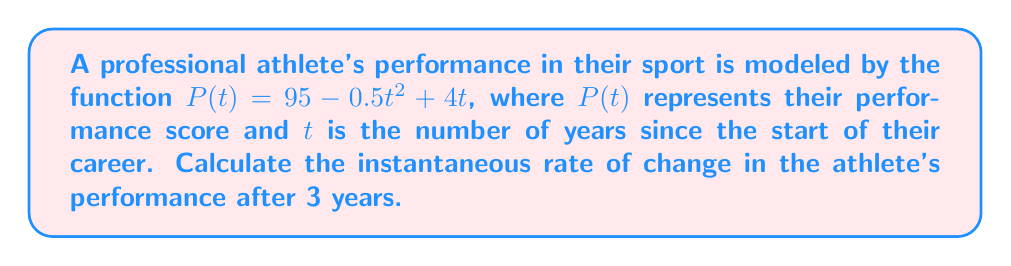What is the answer to this math problem? To find the instantaneous rate of change, we need to calculate the derivative of the function $P(t)$ and evaluate it at $t = 3$.

Step 1: Find the derivative of $P(t)$
$$\frac{d}{dt}P(t) = \frac{d}{dt}(95 - 0.5t^2 + 4t)$$
$$P'(t) = -t + 4$$

Step 2: Evaluate the derivative at $t = 3$
$$P'(3) = -3 + 4 = 1$$

The instantaneous rate of change is the value of the derivative at the given point. In this case, it's 1 point per year when $t = 3$.

This positive value indicates that the athlete's performance is still improving after 3 years, but at a slower rate than initially. The athlete might want to keep this information confidential to maintain a competitive advantage.
Answer: 1 point/year 